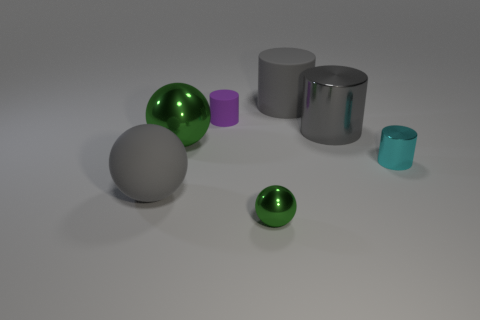Add 1 gray rubber cylinders. How many objects exist? 8 Subtract all cylinders. How many objects are left? 3 Subtract all tiny matte objects. Subtract all purple rubber objects. How many objects are left? 5 Add 5 large gray matte spheres. How many large gray matte spheres are left? 6 Add 3 small brown matte balls. How many small brown matte balls exist? 3 Subtract 1 purple cylinders. How many objects are left? 6 